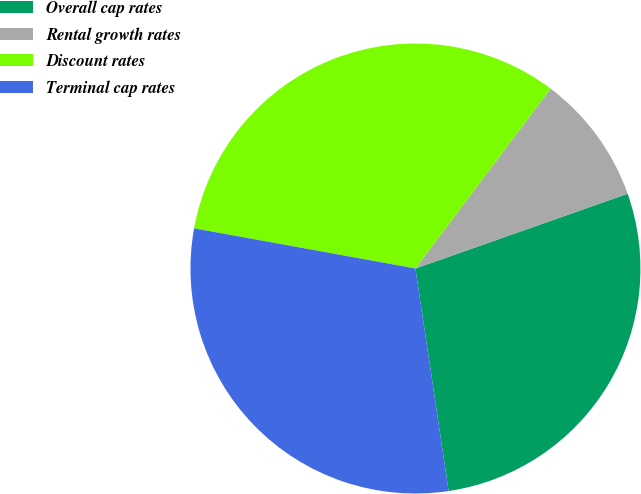Convert chart. <chart><loc_0><loc_0><loc_500><loc_500><pie_chart><fcel>Overall cap rates<fcel>Rental growth rates<fcel>Discount rates<fcel>Terminal cap rates<nl><fcel>28.04%<fcel>9.35%<fcel>32.4%<fcel>30.22%<nl></chart> 